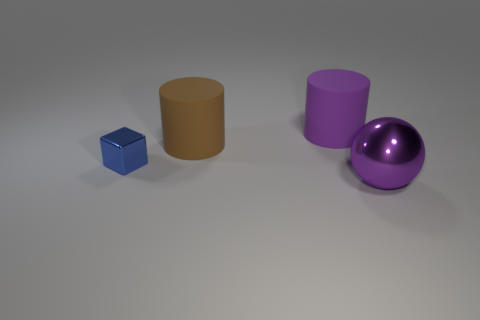Add 2 large brown things. How many objects exist? 6 Subtract 0 brown cubes. How many objects are left? 4 Subtract all big balls. Subtract all small brown rubber spheres. How many objects are left? 3 Add 3 tiny cubes. How many tiny cubes are left? 4 Add 2 large brown rubber things. How many large brown rubber things exist? 3 